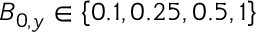<formula> <loc_0><loc_0><loc_500><loc_500>B _ { 0 , y } \in \left \{ 0 . 1 , 0 . 2 5 , 0 . 5 , 1 \right \}</formula> 